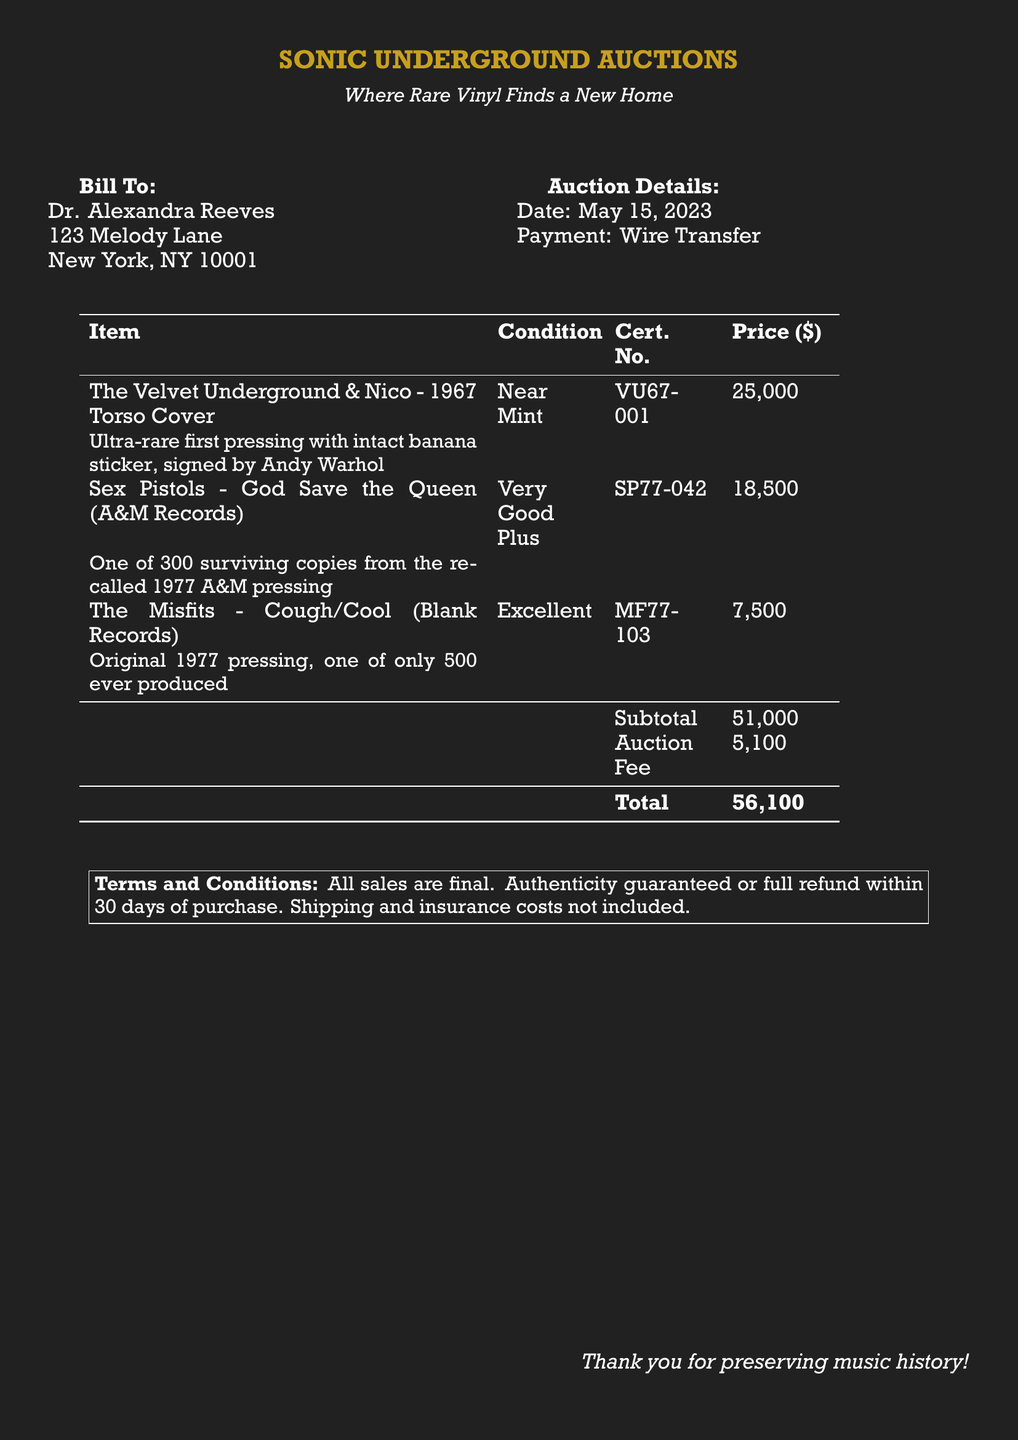What is the name of the auction house? The auction house is named "SONIC UNDERGROUND AUCTIONS," as indicated at the top of the document.
Answer: SONIC UNDERGROUND AUCTIONS What is the total amount due? The total amount due is explicitly stated in the document in the total section of the bill.
Answer: 56,100 What is the condition of "The Velvet Underground & Nico"? The condition is noted in the item table, next to the title of the record.
Answer: Near Mint Who is the bill addressed to? The recipient's name is listed at the top of the bill.
Answer: Dr. Alexandra Reeves What item has the highest price? The prices of the items are listed in the table, and the item with the highest price can be determined from this.
Answer: The Velvet Underground & Nico - 1967 Torso Cover How much is the auction fee? The auction fee is outlined separately in the document, under the subtotal.
Answer: 5,100 What is the certificate number for "God Save the Queen"? The certificate number can be found next to the item's title in the table of items.
Answer: SP77-042 What date was the auction held? The date of the auction is specified in the auction details section of the bill.
Answer: May 15, 2023 What type of payment was used? The payment method is mentioned in the auction details section.
Answer: Wire Transfer 